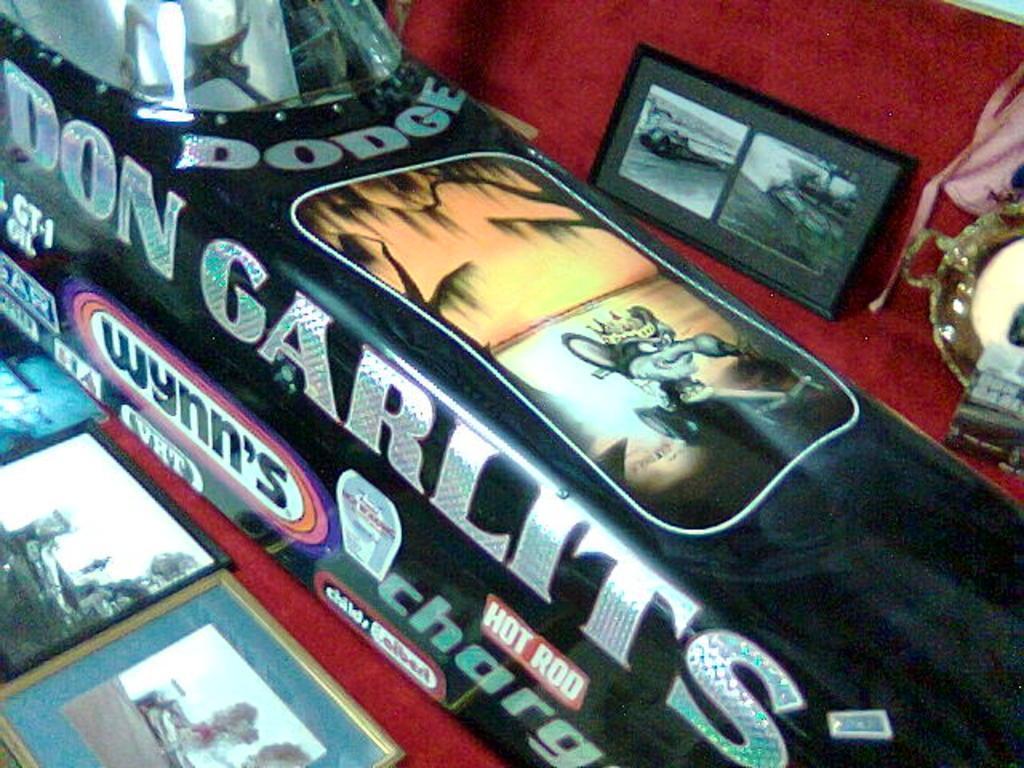Can you describe this image briefly? In this image we can see photo frames, black color object and a few objects kept on red color surface. 